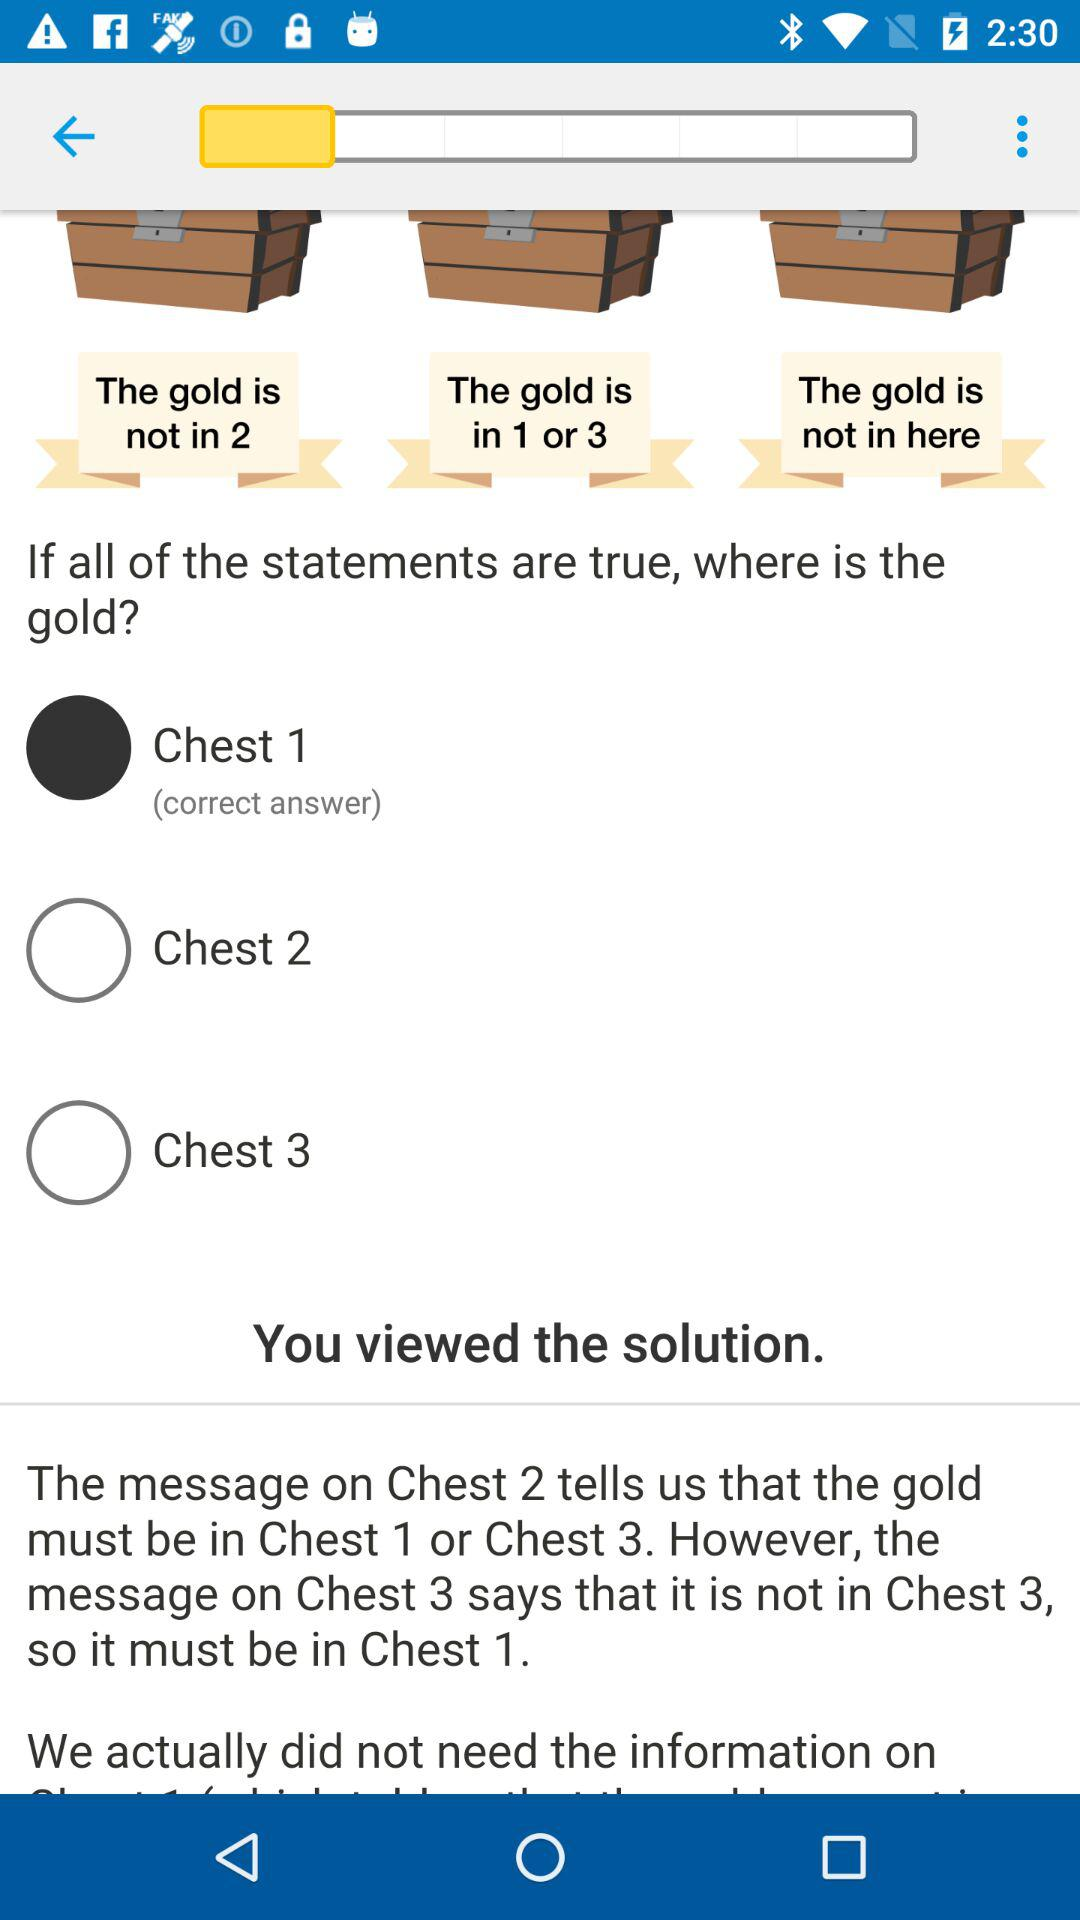What is the correct answer? The correct answer is "Chest 1". 